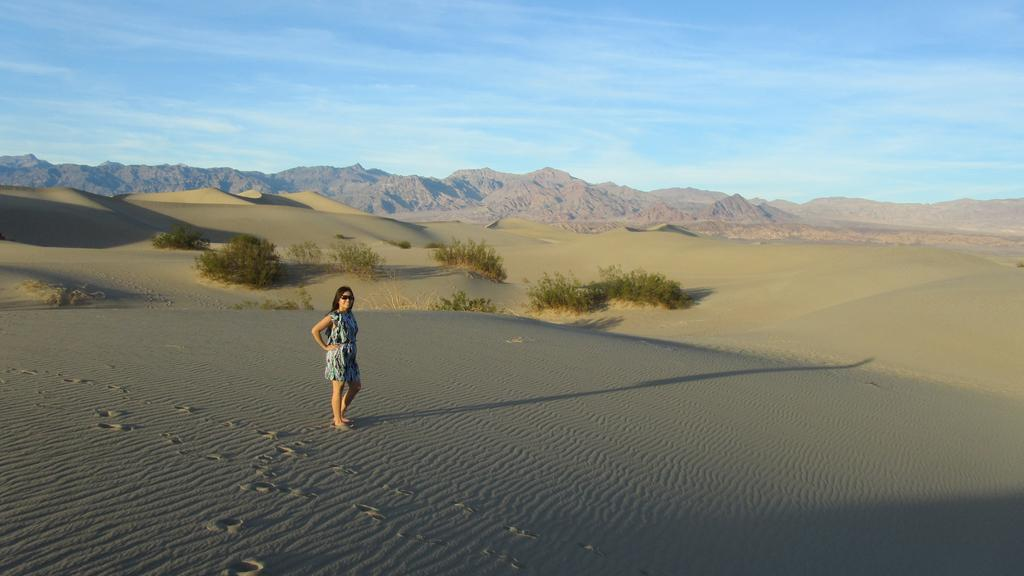Who is present in the image? There is a woman in the image. What is the woman wearing on her face? The woman is wearing goggles. Where is the woman standing? The woman is standing on the sand. What type of vegetation is visible behind the woman? There are plants behind the woman. What natural feature can be seen in the distance? There are mountains in the background of the image. What tooth is the woman using to dig in the sand? The woman is not using a tooth to dig in the sand; she is standing on the sand with goggles on. 